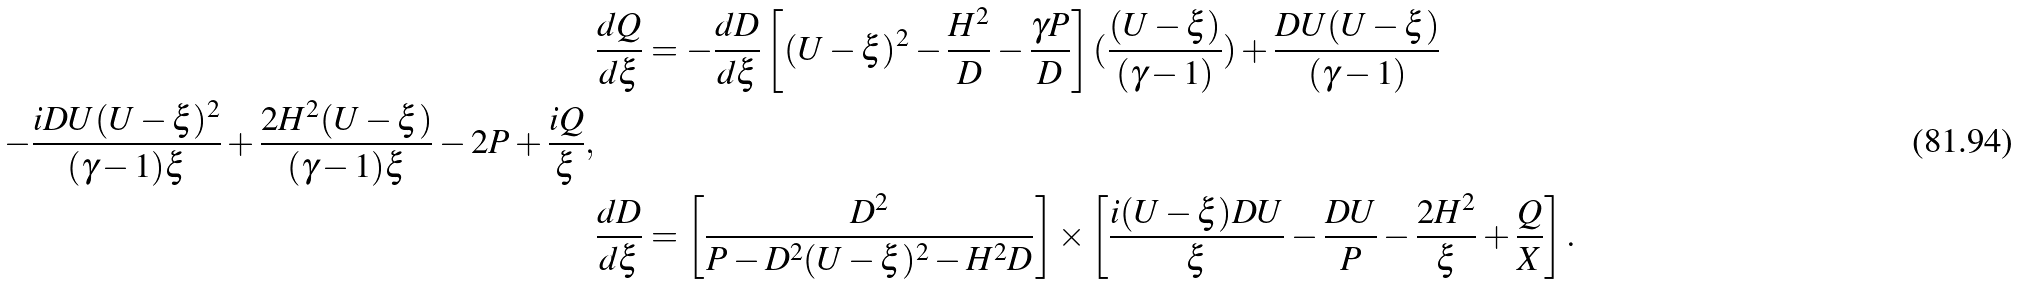<formula> <loc_0><loc_0><loc_500><loc_500>& \frac { d Q } { d \xi } = - \frac { d D } { d \xi } \left [ ( U - \xi ) ^ { 2 } - \frac { H ^ { 2 } } { D } - \frac { \gamma P } { D } \right ] ( \frac { ( U - \xi ) } { ( \gamma - 1 ) } ) + \frac { D U ( U - \xi ) } { ( \gamma - 1 ) } \\ - \frac { i D U ( U - \xi ) ^ { 2 } } { ( \gamma - 1 ) \xi } + \frac { 2 H ^ { 2 } ( U - \xi ) } { ( \gamma - 1 ) \xi } - 2 P + \frac { i Q } { \xi } , \\ & \frac { d D } { d \xi } = \left [ \frac { D ^ { 2 } } { P - D ^ { 2 } ( U - \xi ) ^ { 2 } - H ^ { 2 } D } \right ] \times \left [ \frac { i ( U - \xi ) D U } { \xi } - \frac { D U } { P } - \frac { 2 H ^ { 2 } } { \xi } + \frac { Q } { X } \right ] .</formula> 